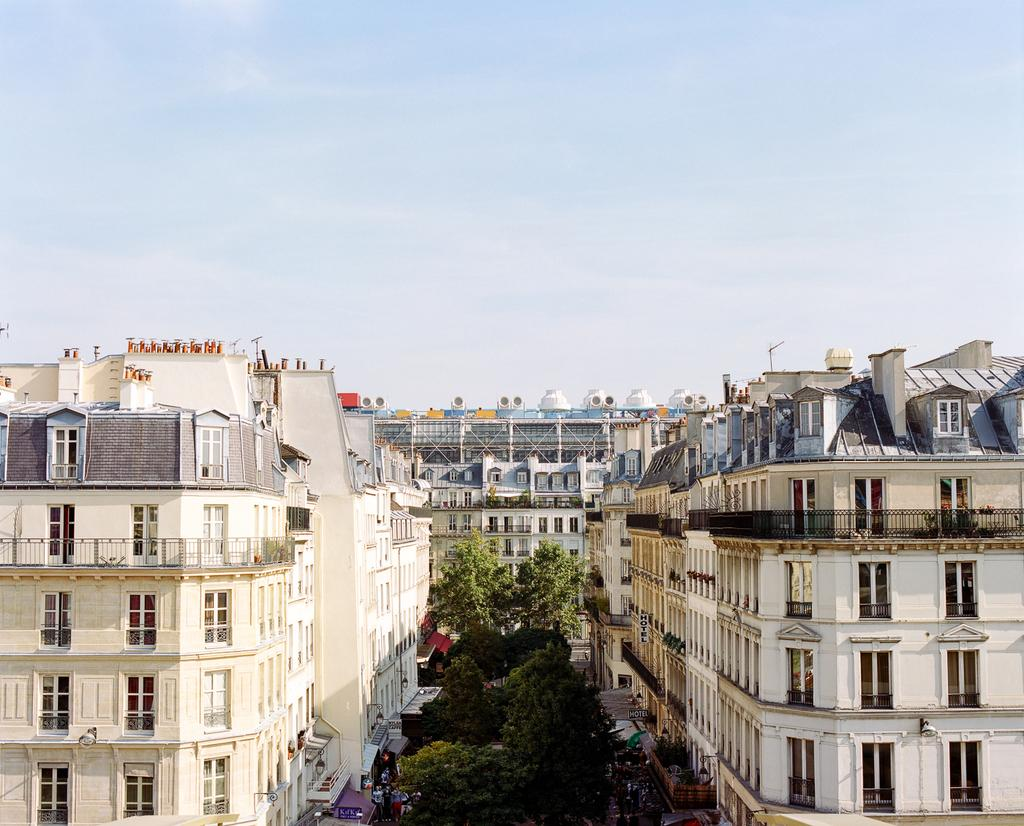What type of vegetation can be seen in the image? There are trees in the image. What type of structures are present in the image? There are buildings with windows in the image. What is visible in the background of the image? The sky is visible in the background of the image. How much salt is present on the buildings in the image? There is no mention of salt in the image, and therefore it cannot be determined if any salt is present. What causes the buildings to smash in the image? There is no indication of any buildings being smashed in the image. 